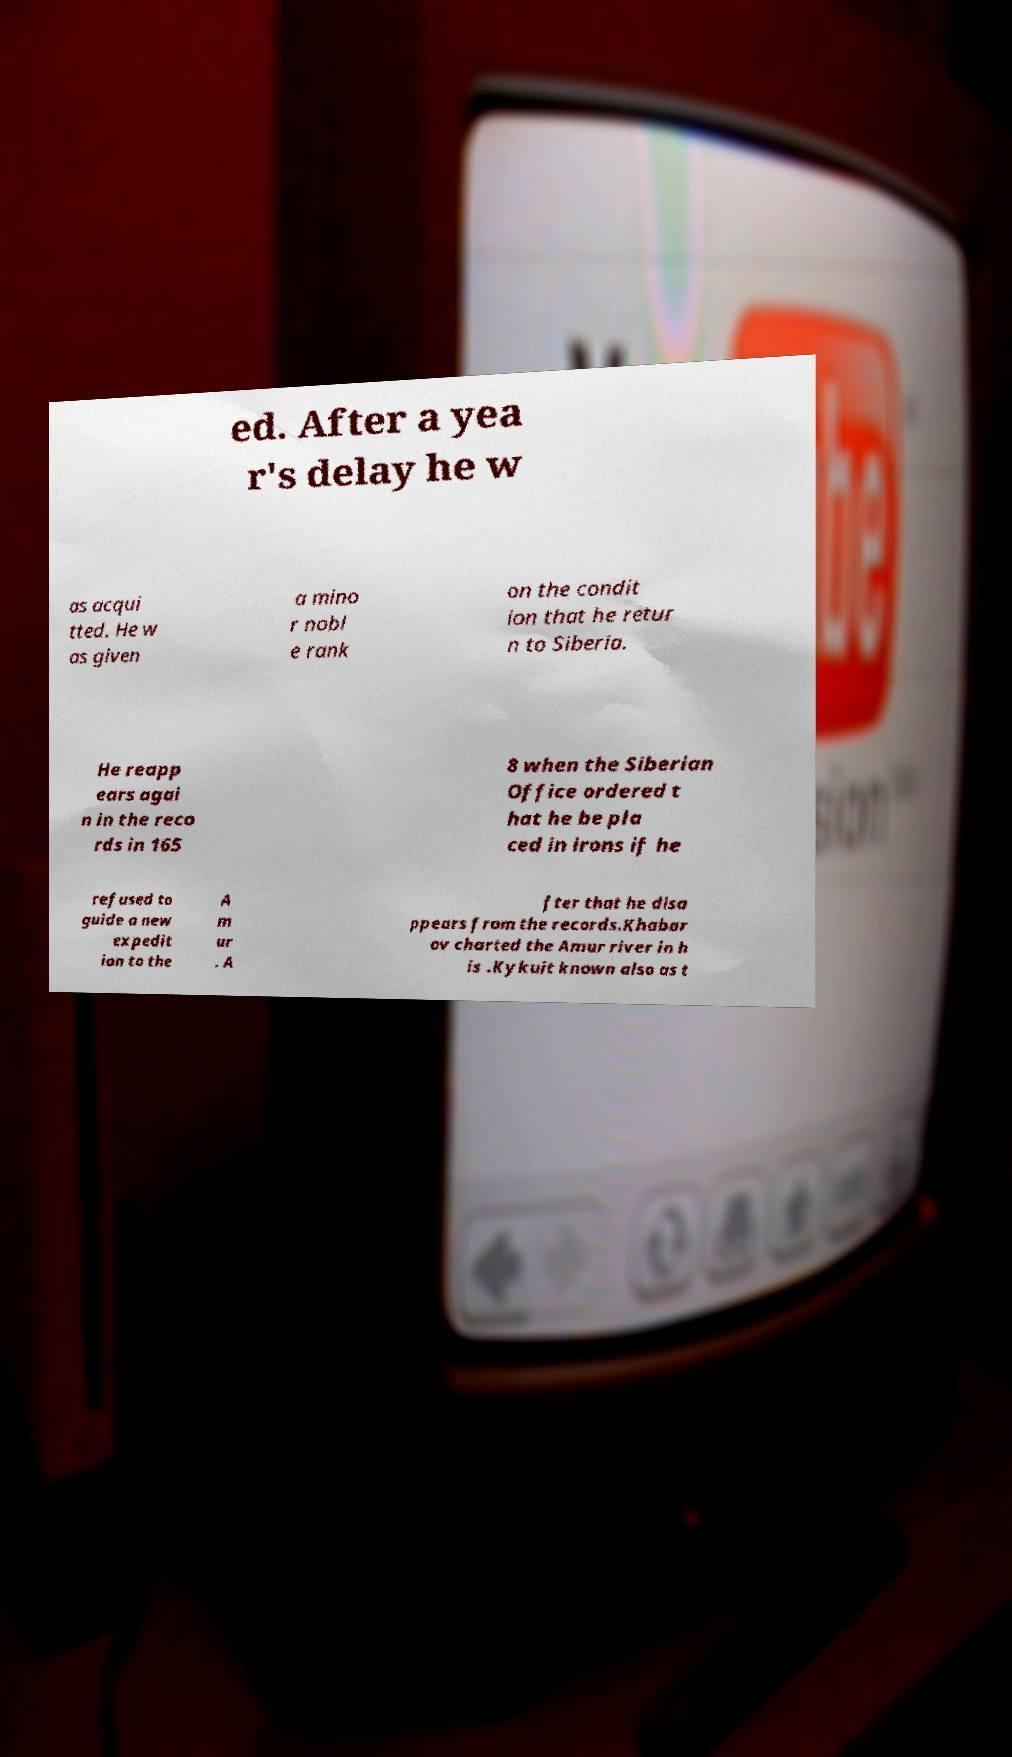I need the written content from this picture converted into text. Can you do that? ed. After a yea r's delay he w as acqui tted. He w as given a mino r nobl e rank on the condit ion that he retur n to Siberia. He reapp ears agai n in the reco rds in 165 8 when the Siberian Office ordered t hat he be pla ced in irons if he refused to guide a new expedit ion to the A m ur . A fter that he disa ppears from the records.Khabar ov charted the Amur river in h is .Kykuit known also as t 